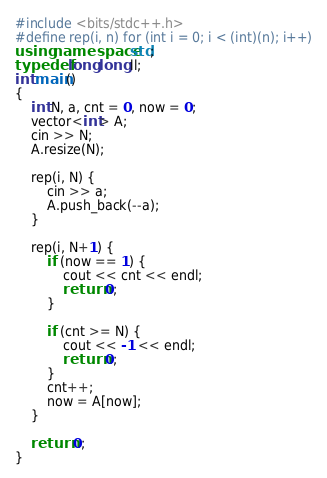Convert code to text. <code><loc_0><loc_0><loc_500><loc_500><_C++_>#include <bits/stdc++.h>
#define rep(i, n) for (int i = 0; i < (int)(n); i++)
using namespace std;
typedef long long ll;
int main()
{
	int N, a, cnt = 0, now = 0;
	vector<int> A;
	cin >> N;
	A.resize(N);

	rep(i, N) {
		cin >> a;
		A.push_back(--a);
	}

	rep(i, N+1) {
		if (now == 1) {
			cout << cnt << endl;
			return 0;
		}
		
		if (cnt >= N) {
			cout << -1 << endl;
			return 0;
		}
		cnt++;
		now = A[now];
	}

	return 0;
}</code> 